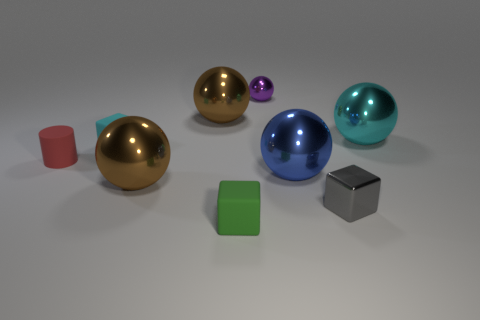Subtract all blocks. How many objects are left? 6 Subtract all cyan spheres. How many spheres are left? 4 Subtract all tiny purple spheres. How many spheres are left? 4 Subtract 5 balls. How many balls are left? 0 Subtract all green spheres. Subtract all purple blocks. How many spheres are left? 5 Subtract all blue spheres. How many gray cylinders are left? 0 Subtract all purple objects. Subtract all green metal balls. How many objects are left? 8 Add 6 tiny gray shiny blocks. How many tiny gray shiny blocks are left? 7 Add 4 big cyan things. How many big cyan things exist? 5 Subtract 0 red balls. How many objects are left? 9 